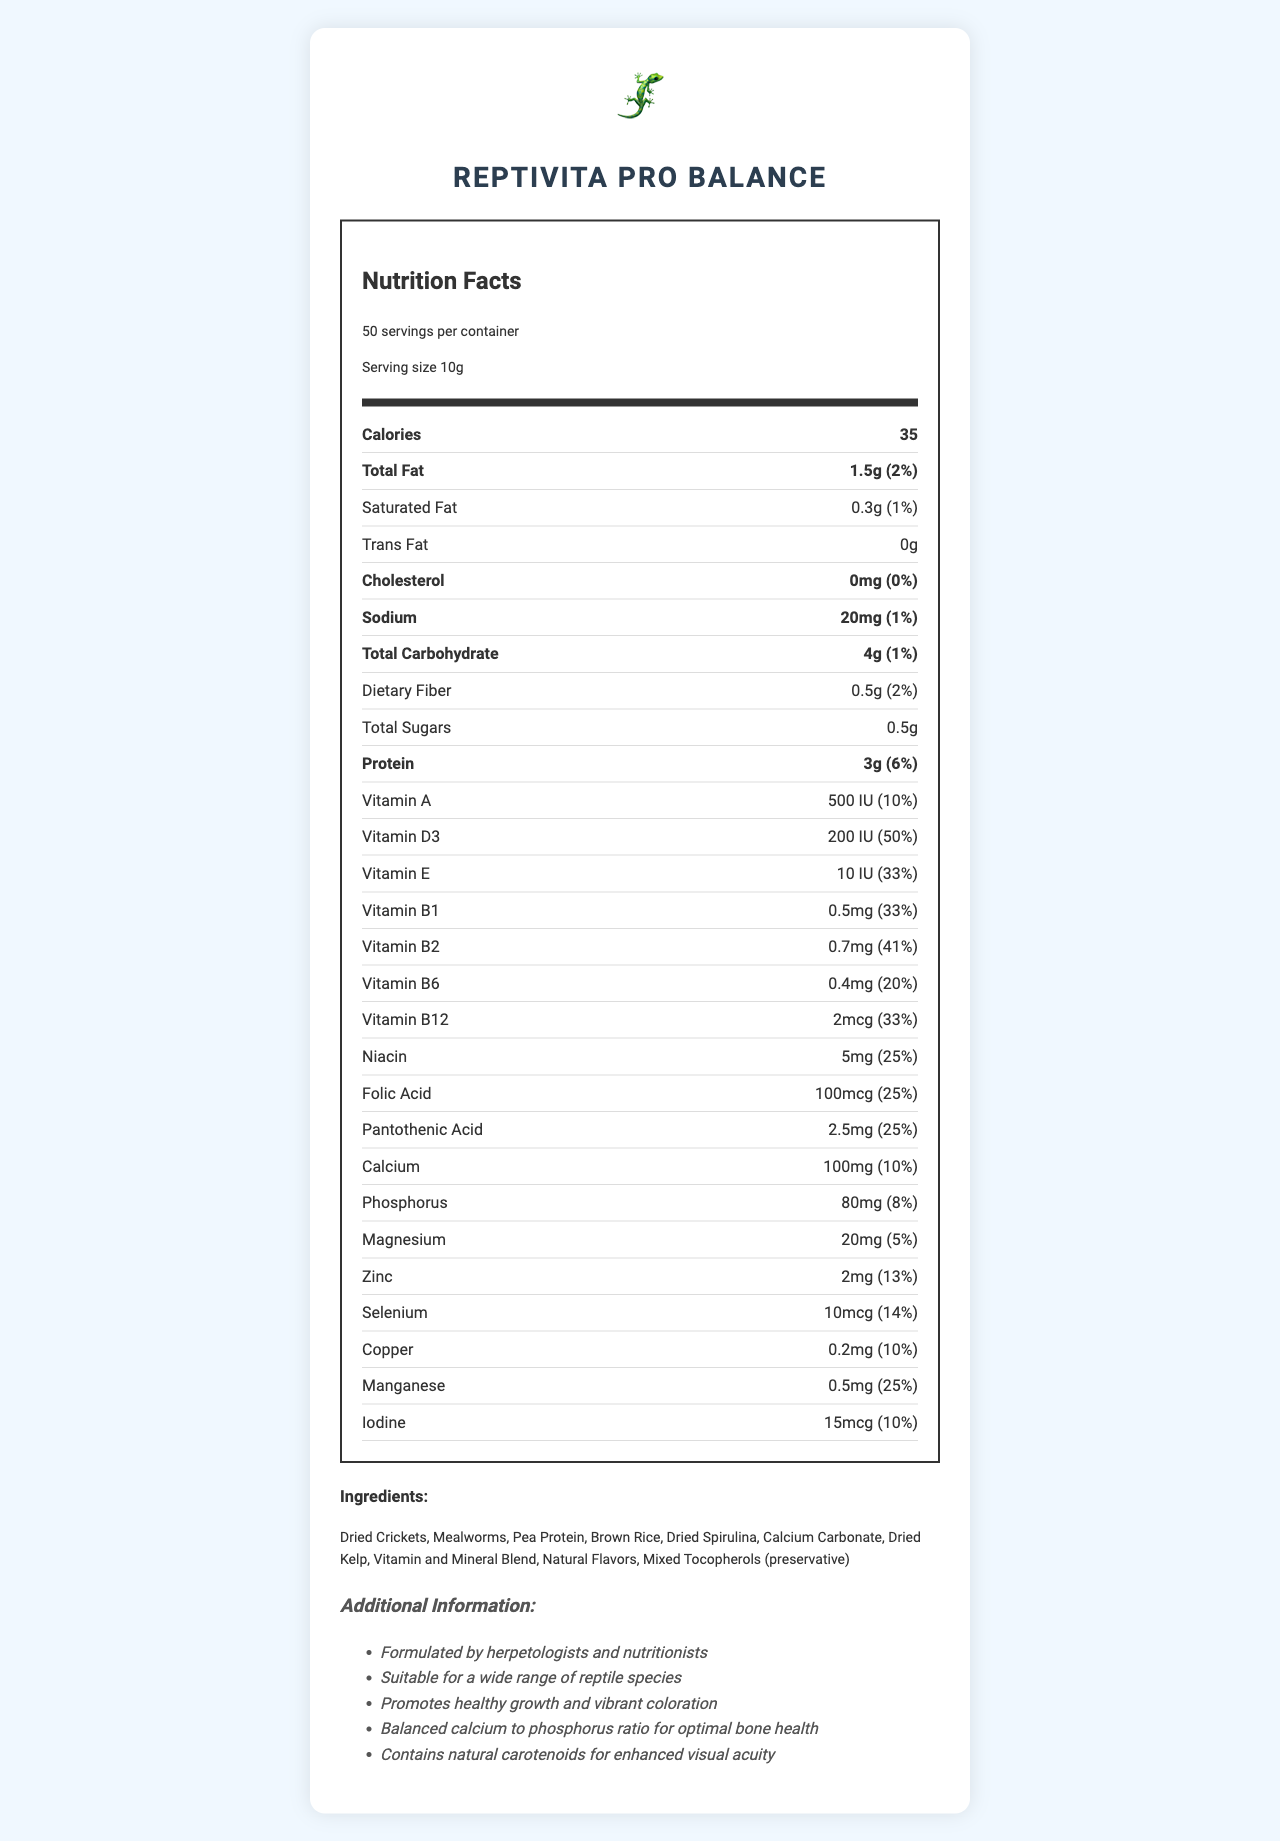what is the product name? The product name is prominently displayed at the top of the document.
Answer: ReptiVita Pro Balance How many servings are there per container? The document lists "50 servings per container" near the top under the nutrition facts header.
Answer: 50 What is the serving size? Serving size is mentioned as "10g" in the introductory part of the nutritional facts section.
Answer: 10g How many calories are there per serving? The number of calories per serving is displayed as 35 under the Calories section.
Answer: 35 What is the amount of calcium per serving? Calcium amount is listed as "100mg" in the nutrients section.
Answer: 100mg How much Vitamin D3 is in one serving? A. 100 IU B. 200 IU C. 300 IU It is stated that Vitamin D3 content per serving is "200 IU".
Answer: B What is the percentage daily value for Vitamin B2 provided per serving? A. 25% B. 33% C. 41% D. 50% The document lists the daily value of Vitamin B2 per serving as "41%".
Answer: C Does the food contain any trans fat? The amount of trans fat is listed as "0g" indicating there is no trans fat.
Answer: No Is this reptile food suitable for a wide range of species? The additional information states that it is suitable for a wide range of reptile species.
Answer: Yes Please summarize the main idea of the document. The document provides a comprehensive nutrition label detailing the serving size, calorie content, nutrients, ingredients, and additional health benefits for reptiles.
Answer: ReptiVita Pro Balance is a balanced, commercially-prepared reptile food designed for optimal health. It contains essential vitamins and minerals, promotes healthy growth, vibrant coloration, and supports bone health with a balanced calcium to phosphorus ratio. Does this food include dried crickets as an ingredient? "Dried Crickets" is explicitly listed as one of the ingredients.
Answer: Yes Can it be determined how this food was formulated? The additional information states that it was formulated by herpetologists and nutritionists.
Answer: Yes What is the total amount of protein per serving and its daily value percentage? The protein content is listed as 3g per serving, with a daily value of 6%.
Answer: 3g, 6% What are the main components of the vitamin and mineral blend? The document lists "Vitamin and Mineral Blend" as an ingredient, but does not provide details on the specific components included in this blend.
Answer: Cannot be determined 